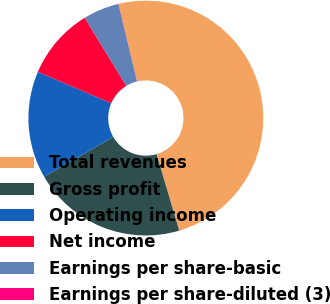Convert chart to OTSL. <chart><loc_0><loc_0><loc_500><loc_500><pie_chart><fcel>Total revenues<fcel>Gross profit<fcel>Operating income<fcel>Net income<fcel>Earnings per share-basic<fcel>Earnings per share-diluted (3)<nl><fcel>49.15%<fcel>21.26%<fcel>14.77%<fcel>9.85%<fcel>4.94%<fcel>0.03%<nl></chart> 